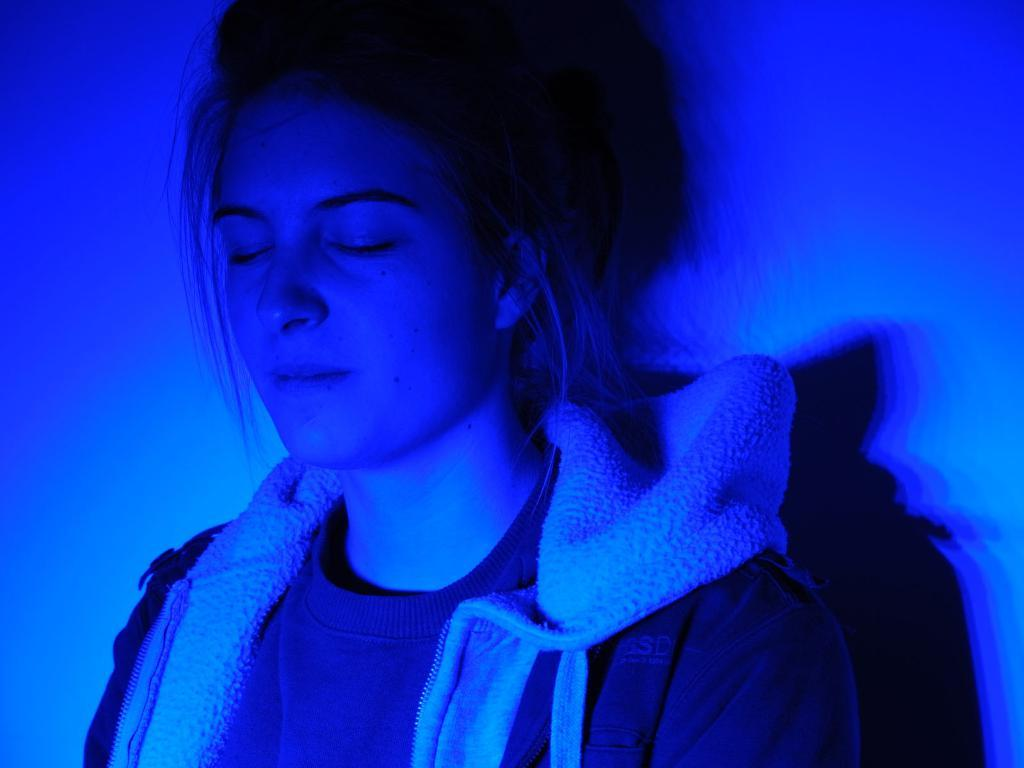Who is present in the image? There is a woman in the image. What is the woman wearing? The woman is wearing a jacket. What is the woman doing in the image? The woman has closed her eyes. What type of quiver can be seen on the woman's back in the image? There is no quiver present on the woman's back in the image. How many cakes are visible on the table in the image? There is no table or cakes present in the image. 